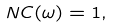Convert formula to latex. <formula><loc_0><loc_0><loc_500><loc_500>N C ( \omega ) = 1 ,</formula> 